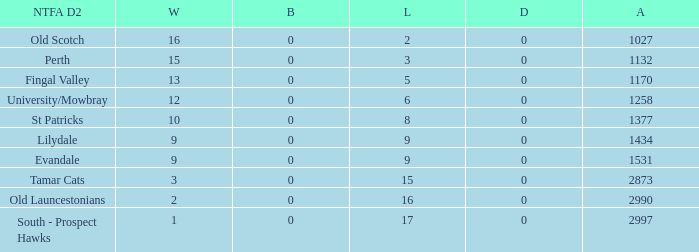What is the lowest number of draws of the team with 9 wins and less than 0 byes? None. 